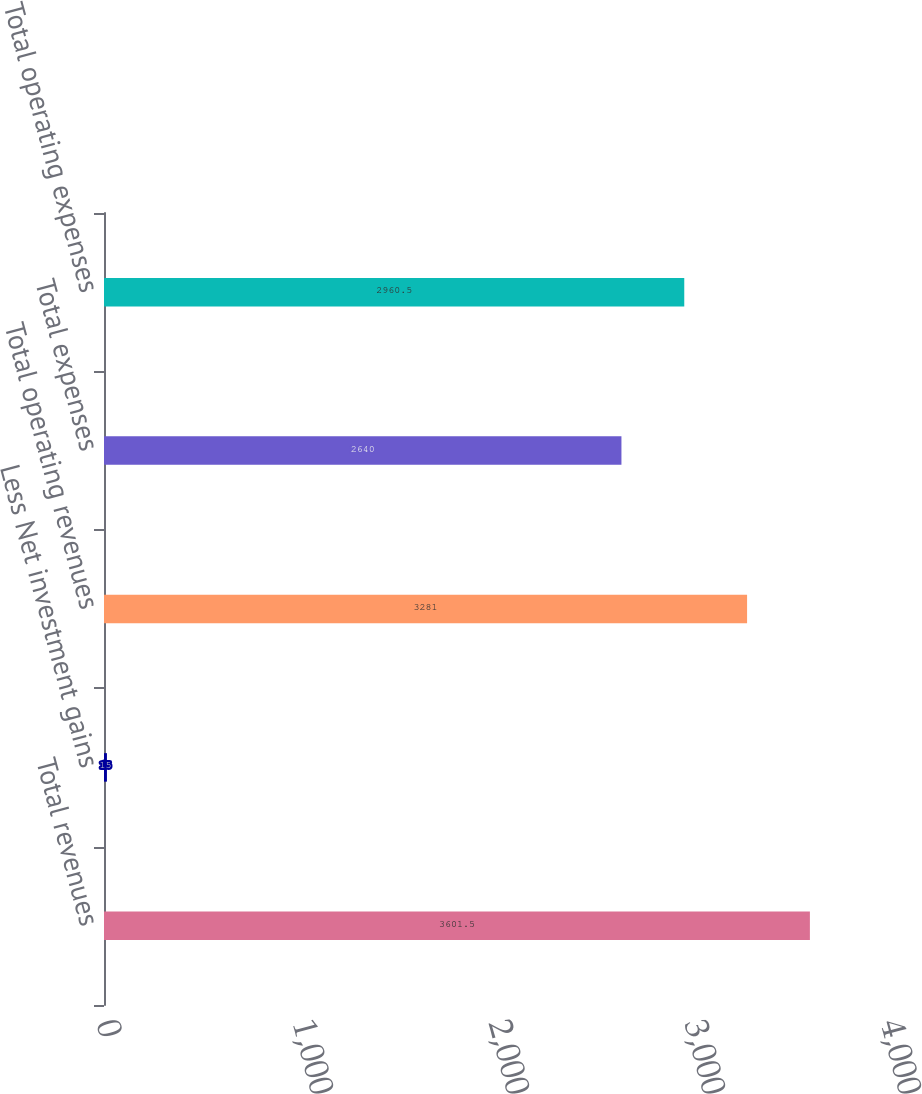Convert chart to OTSL. <chart><loc_0><loc_0><loc_500><loc_500><bar_chart><fcel>Total revenues<fcel>Less Net investment gains<fcel>Total operating revenues<fcel>Total expenses<fcel>Total operating expenses<nl><fcel>3601.5<fcel>15<fcel>3281<fcel>2640<fcel>2960.5<nl></chart> 